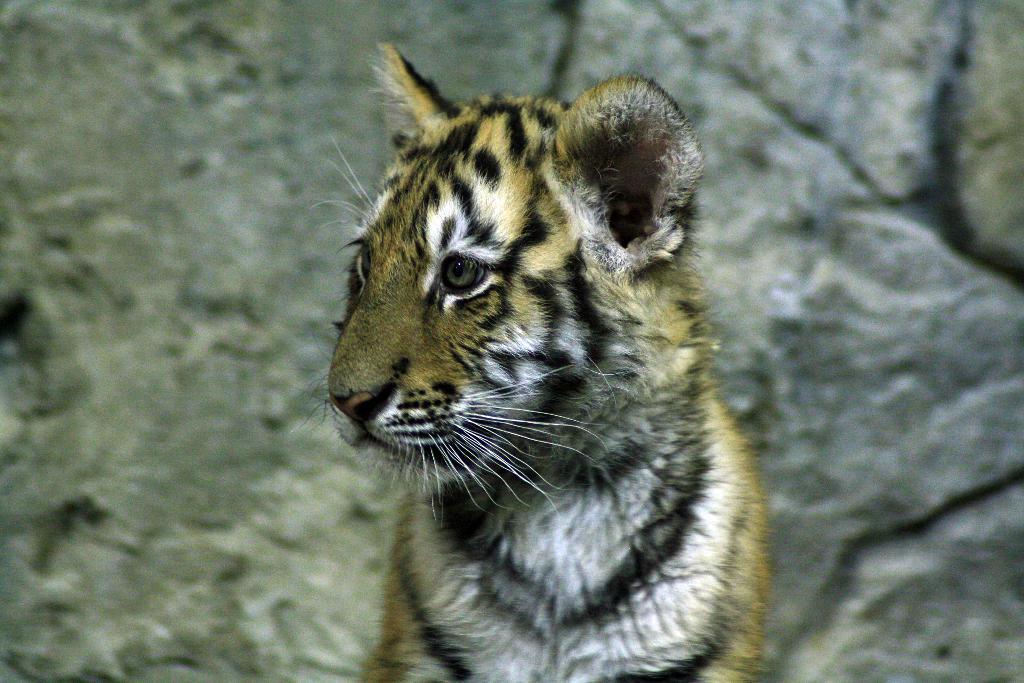Can you describe this image briefly? In the image there is a tiger in front of rocky wall. 